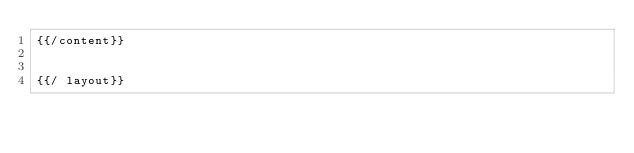<code> <loc_0><loc_0><loc_500><loc_500><_HTML_>{{/content}}


{{/ layout}}
</code> 